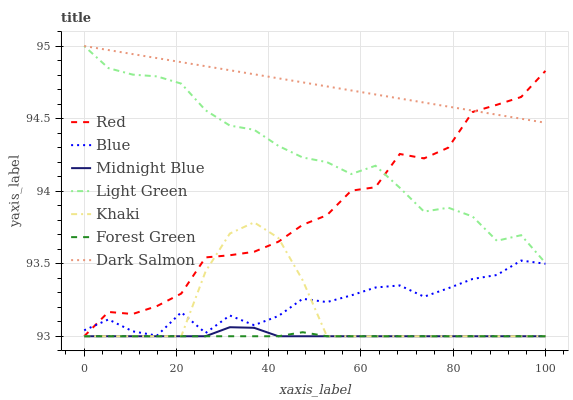Does Khaki have the minimum area under the curve?
Answer yes or no. No. Does Khaki have the maximum area under the curve?
Answer yes or no. No. Is Khaki the smoothest?
Answer yes or no. No. Is Khaki the roughest?
Answer yes or no. No. Does Dark Salmon have the lowest value?
Answer yes or no. No. Does Khaki have the highest value?
Answer yes or no. No. Is Midnight Blue less than Dark Salmon?
Answer yes or no. Yes. Is Blue greater than Forest Green?
Answer yes or no. Yes. Does Midnight Blue intersect Dark Salmon?
Answer yes or no. No. 